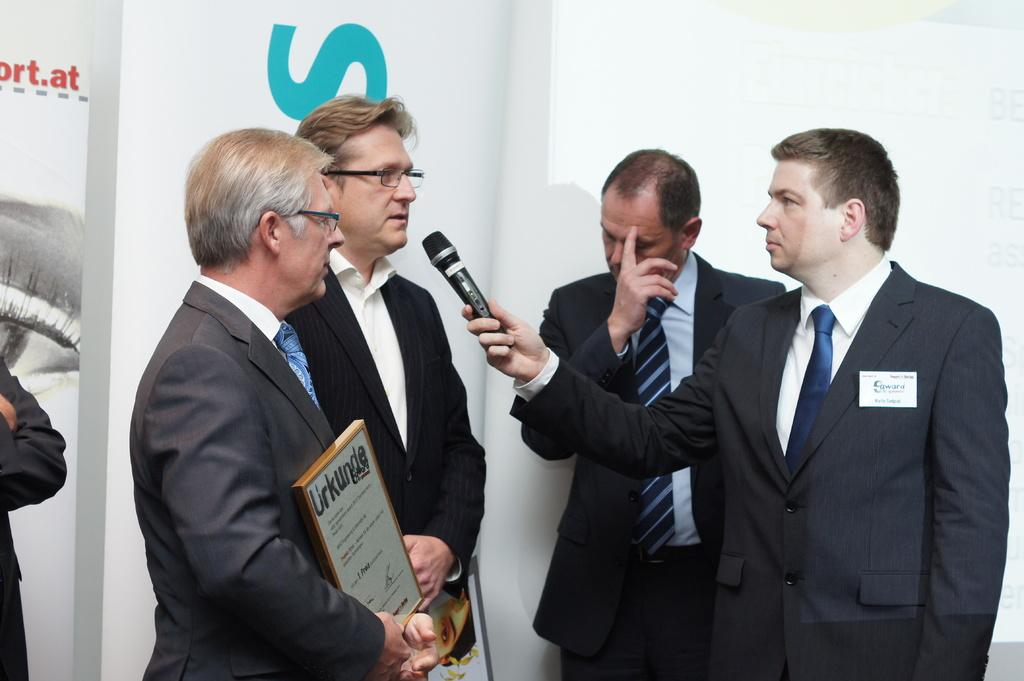What are the people in the image doing? The people in the image are standing. Can you describe what one person is holding in their hand? One person is holding a microphone in their hand. What is another person holding in their hand? Another person is holding a photo frame in their hand. What type of volleyball is being played in the image? There is no volleyball present in the image. How much profit did the person holding the photo frame make from their last sale? There is no information about profit or sales in the image. 